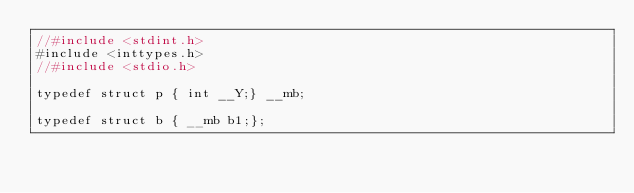<code> <loc_0><loc_0><loc_500><loc_500><_C++_>//#include <stdint.h>
#include <inttypes.h>
//#include <stdio.h>

typedef struct p { int __Y;} __mb;

typedef struct b { __mb b1;};

</code> 